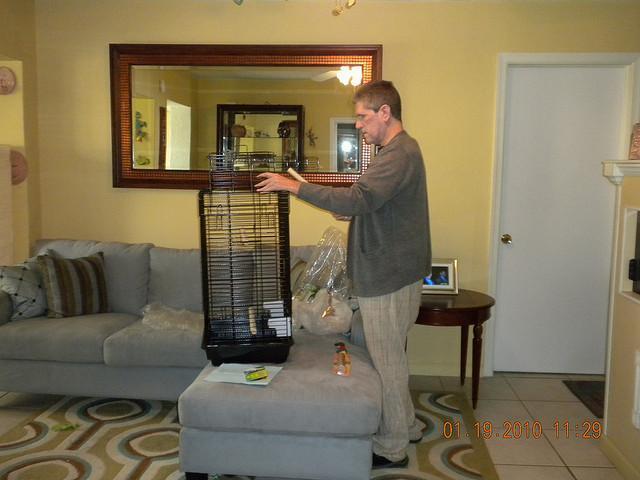How many couches can you see?
Give a very brief answer. 2. 